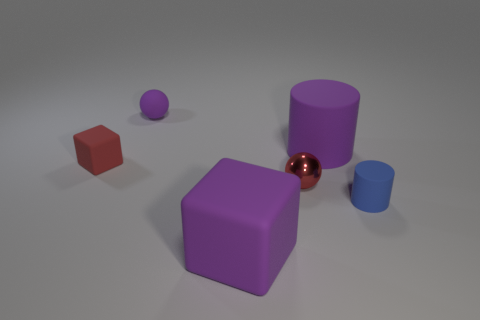Add 4 tiny metal cylinders. How many objects exist? 10 Subtract all balls. How many objects are left? 4 Subtract all big yellow spheres. Subtract all purple rubber spheres. How many objects are left? 5 Add 4 big rubber blocks. How many big rubber blocks are left? 5 Add 3 large cylinders. How many large cylinders exist? 4 Subtract 0 yellow blocks. How many objects are left? 6 